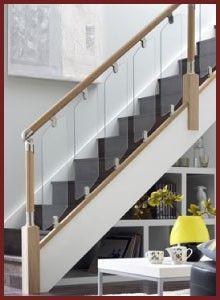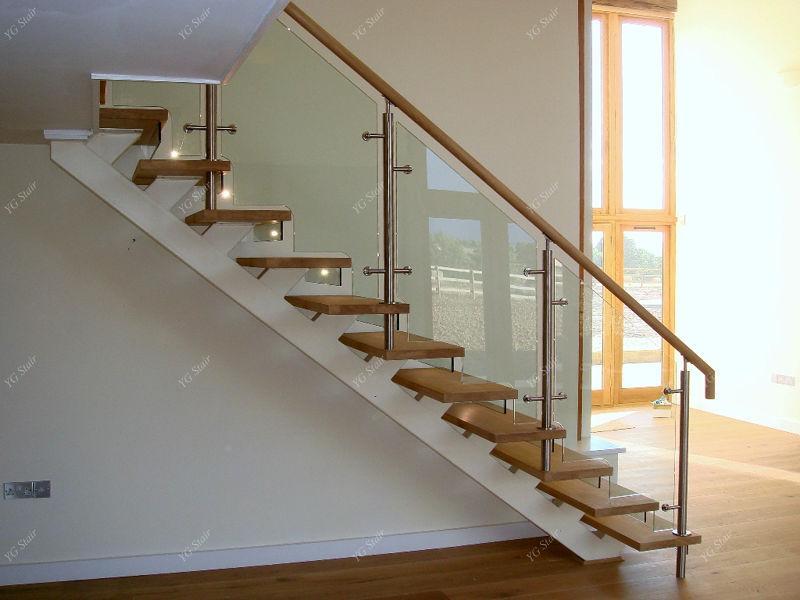The first image is the image on the left, the second image is the image on the right. Evaluate the accuracy of this statement regarding the images: "The end of white-faced built-in shelves can be seen in the angled space under a set of stairs in one image.". Is it true? Answer yes or no. Yes. The first image is the image on the left, the second image is the image on the right. For the images shown, is this caption "One image shows a staircase leading down to the right, with glass panels along the side and flat brown wooden backless steps." true? Answer yes or no. Yes. 